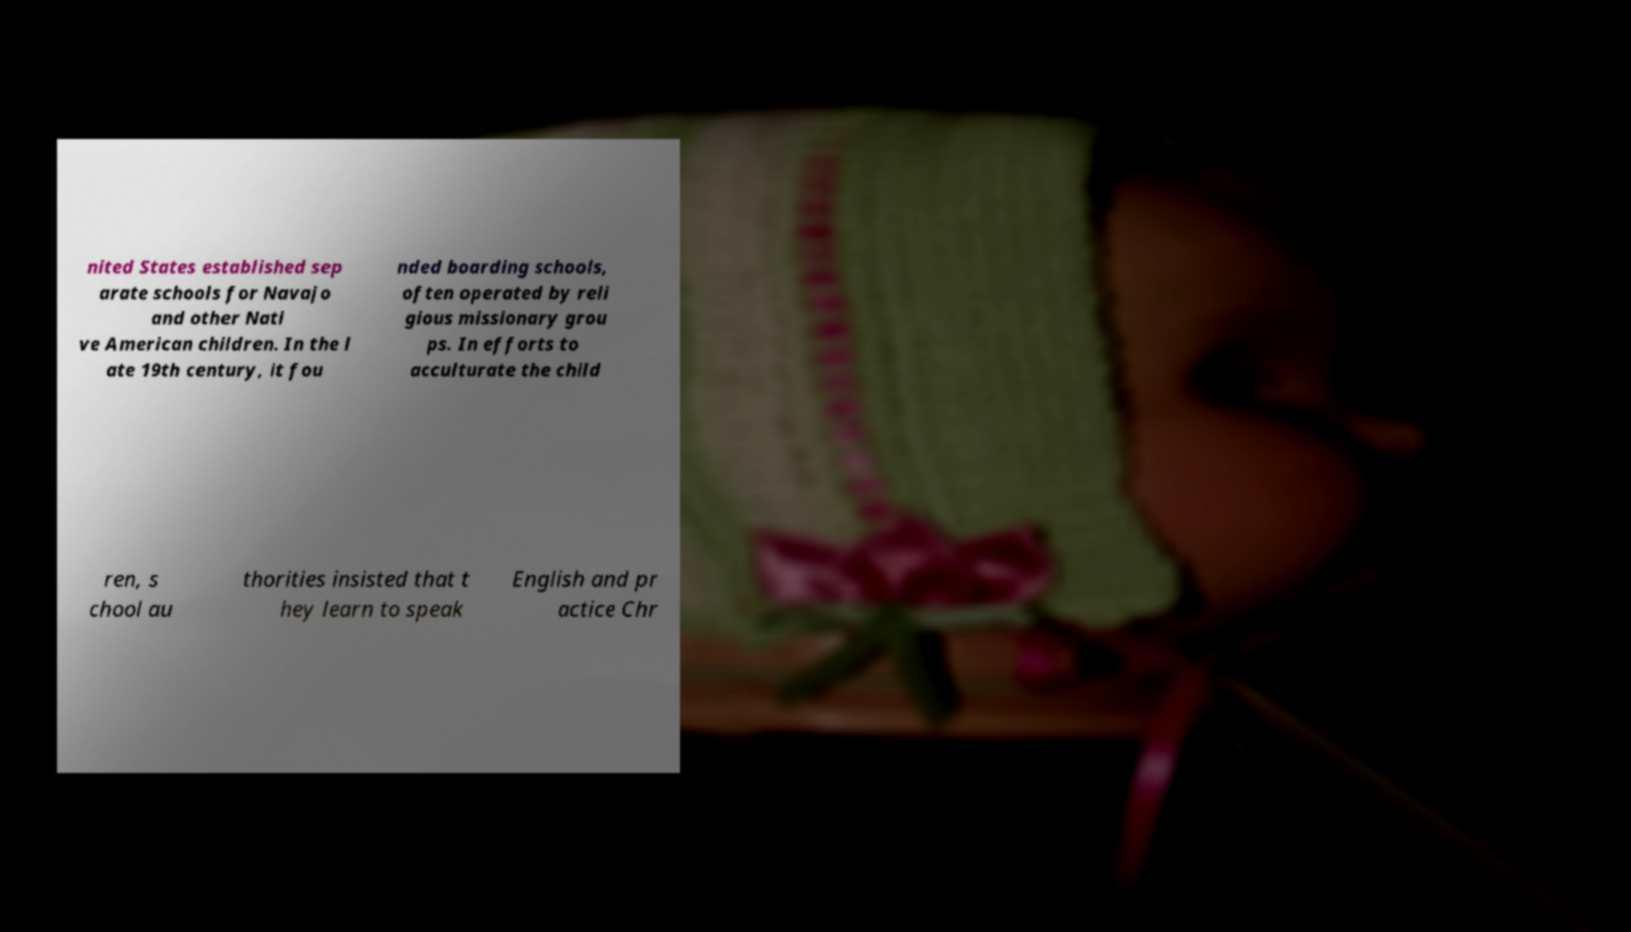Could you extract and type out the text from this image? nited States established sep arate schools for Navajo and other Nati ve American children. In the l ate 19th century, it fou nded boarding schools, often operated by reli gious missionary grou ps. In efforts to acculturate the child ren, s chool au thorities insisted that t hey learn to speak English and pr actice Chr 